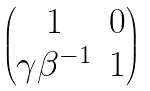<formula> <loc_0><loc_0><loc_500><loc_500>\begin{pmatrix} 1 & 0 \\ \gamma \beta ^ { - 1 } & 1 \end{pmatrix}</formula> 